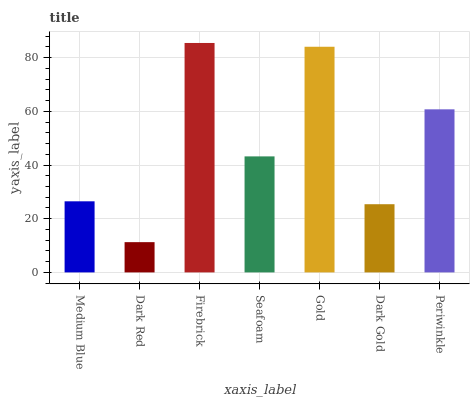Is Dark Red the minimum?
Answer yes or no. Yes. Is Firebrick the maximum?
Answer yes or no. Yes. Is Firebrick the minimum?
Answer yes or no. No. Is Dark Red the maximum?
Answer yes or no. No. Is Firebrick greater than Dark Red?
Answer yes or no. Yes. Is Dark Red less than Firebrick?
Answer yes or no. Yes. Is Dark Red greater than Firebrick?
Answer yes or no. No. Is Firebrick less than Dark Red?
Answer yes or no. No. Is Seafoam the high median?
Answer yes or no. Yes. Is Seafoam the low median?
Answer yes or no. Yes. Is Firebrick the high median?
Answer yes or no. No. Is Firebrick the low median?
Answer yes or no. No. 